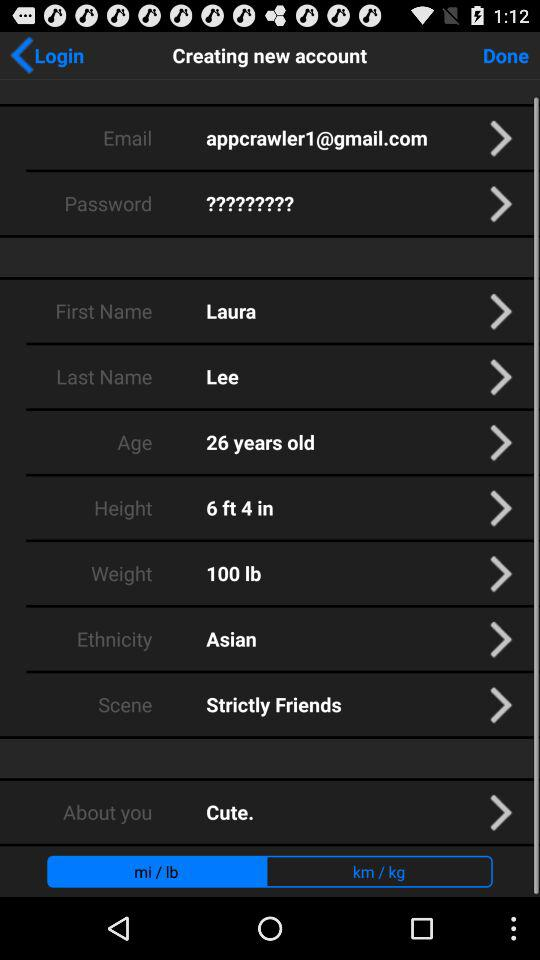What is the last name? The last name is Lee. 